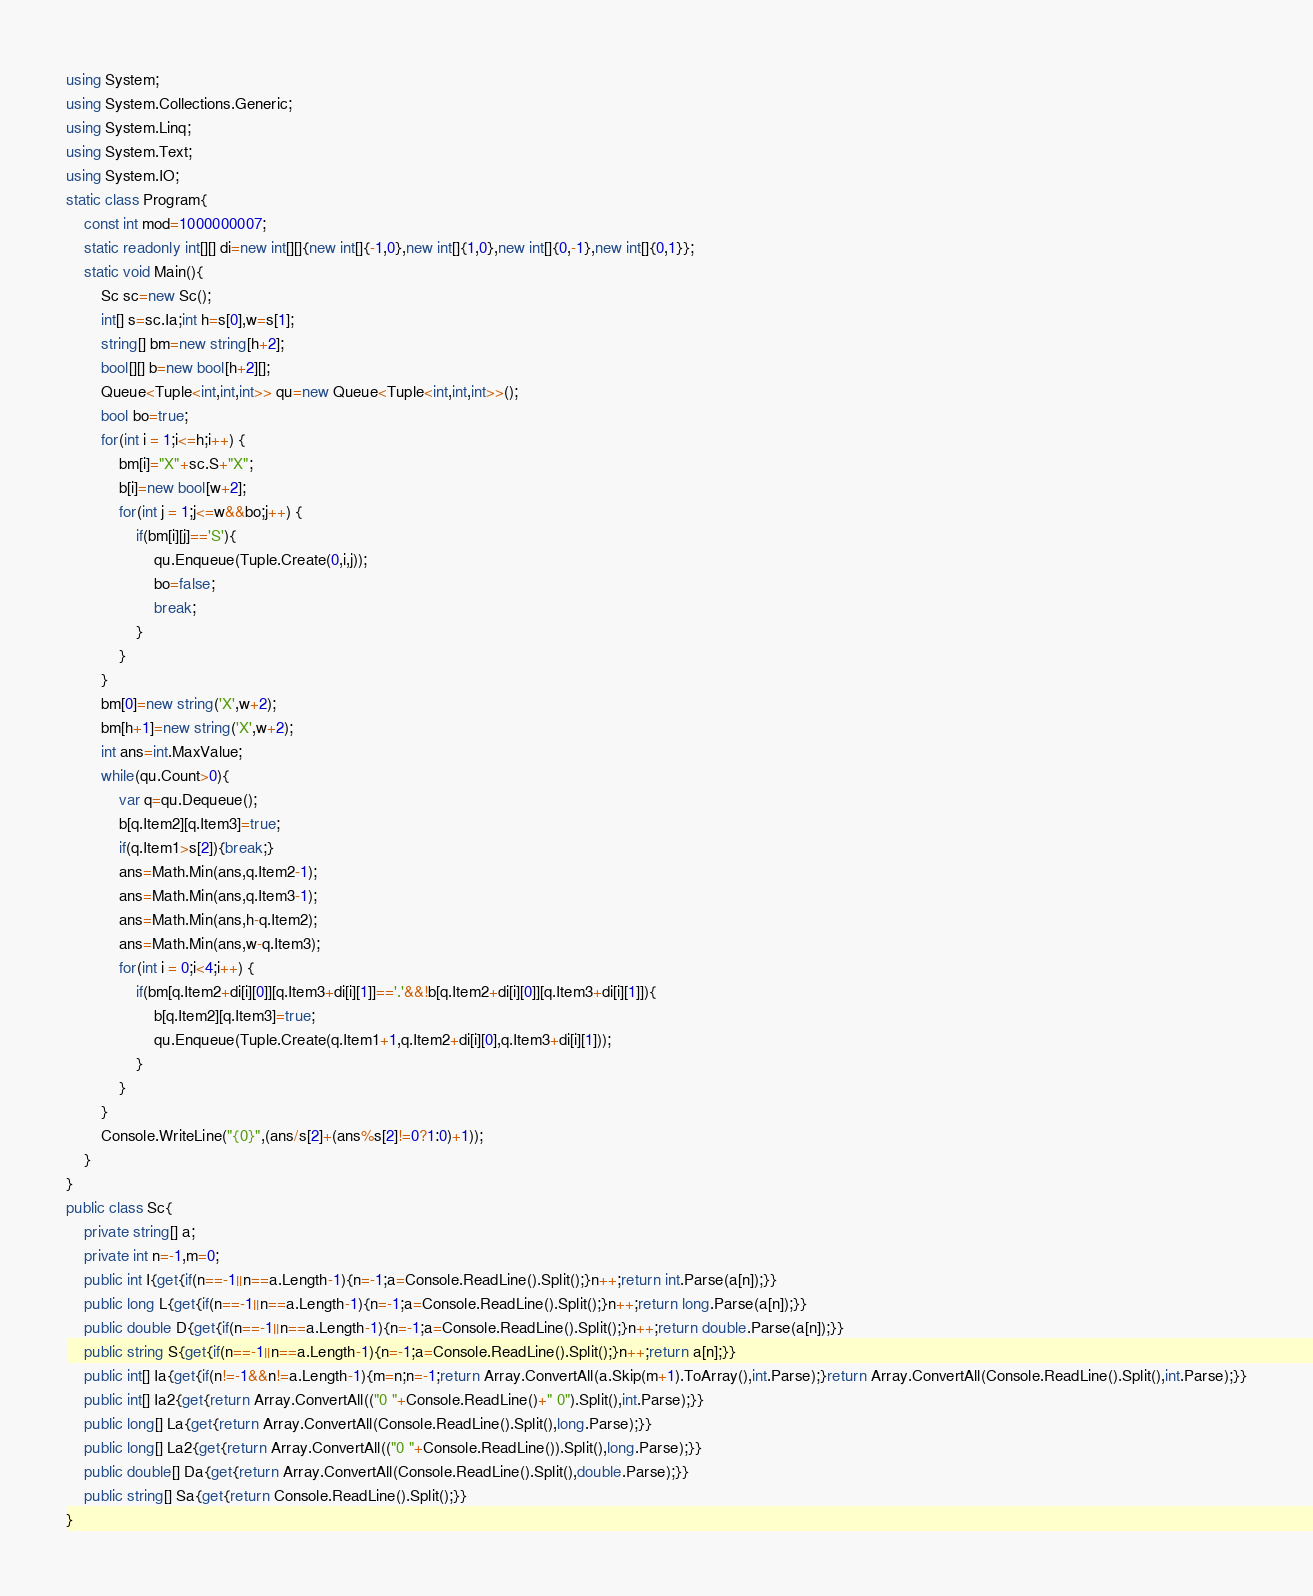Convert code to text. <code><loc_0><loc_0><loc_500><loc_500><_C#_>using System;
using System.Collections.Generic;
using System.Linq;
using System.Text;
using System.IO;
static class Program{
	const int mod=1000000007;
	static readonly int[][] di=new int[][]{new int[]{-1,0},new int[]{1,0},new int[]{0,-1},new int[]{0,1}};
	static void Main(){
		Sc sc=new Sc();
		int[] s=sc.Ia;int h=s[0],w=s[1];
		string[] bm=new string[h+2];
		bool[][] b=new bool[h+2][];
		Queue<Tuple<int,int,int>> qu=new Queue<Tuple<int,int,int>>();
		bool bo=true;
		for(int i = 1;i<=h;i++) {
			bm[i]="X"+sc.S+"X";
			b[i]=new bool[w+2];
			for(int j = 1;j<=w&&bo;j++) {
				if(bm[i][j]=='S'){
					qu.Enqueue(Tuple.Create(0,i,j));
					bo=false;
					break;
				}
			}
		}
		bm[0]=new string('X',w+2);
		bm[h+1]=new string('X',w+2);
		int ans=int.MaxValue;
		while(qu.Count>0){
			var q=qu.Dequeue();
			b[q.Item2][q.Item3]=true;
			if(q.Item1>s[2]){break;}
			ans=Math.Min(ans,q.Item2-1);
			ans=Math.Min(ans,q.Item3-1);
			ans=Math.Min(ans,h-q.Item2);
			ans=Math.Min(ans,w-q.Item3);
			for(int i = 0;i<4;i++) {
				if(bm[q.Item2+di[i][0]][q.Item3+di[i][1]]=='.'&&!b[q.Item2+di[i][0]][q.Item3+di[i][1]]){
					b[q.Item2][q.Item3]=true;
					qu.Enqueue(Tuple.Create(q.Item1+1,q.Item2+di[i][0],q.Item3+di[i][1]));
				}
			}
		}
		Console.WriteLine("{0}",(ans/s[2]+(ans%s[2]!=0?1:0)+1));
	}
}
public class Sc{
	private string[] a;
	private int n=-1,m=0;
	public int I{get{if(n==-1||n==a.Length-1){n=-1;a=Console.ReadLine().Split();}n++;return int.Parse(a[n]);}}
	public long L{get{if(n==-1||n==a.Length-1){n=-1;a=Console.ReadLine().Split();}n++;return long.Parse(a[n]);}}
	public double D{get{if(n==-1||n==a.Length-1){n=-1;a=Console.ReadLine().Split();}n++;return double.Parse(a[n]);}}
	public string S{get{if(n==-1||n==a.Length-1){n=-1;a=Console.ReadLine().Split();}n++;return a[n];}}
	public int[] Ia{get{if(n!=-1&&n!=a.Length-1){m=n;n=-1;return Array.ConvertAll(a.Skip(m+1).ToArray(),int.Parse);}return Array.ConvertAll(Console.ReadLine().Split(),int.Parse);}}
	public int[] Ia2{get{return Array.ConvertAll(("0 "+Console.ReadLine()+" 0").Split(),int.Parse);}}
	public long[] La{get{return Array.ConvertAll(Console.ReadLine().Split(),long.Parse);}}
	public long[] La2{get{return Array.ConvertAll(("0 "+Console.ReadLine()).Split(),long.Parse);}}
	public double[] Da{get{return Array.ConvertAll(Console.ReadLine().Split(),double.Parse);}}
	public string[] Sa{get{return Console.ReadLine().Split();}}
}</code> 